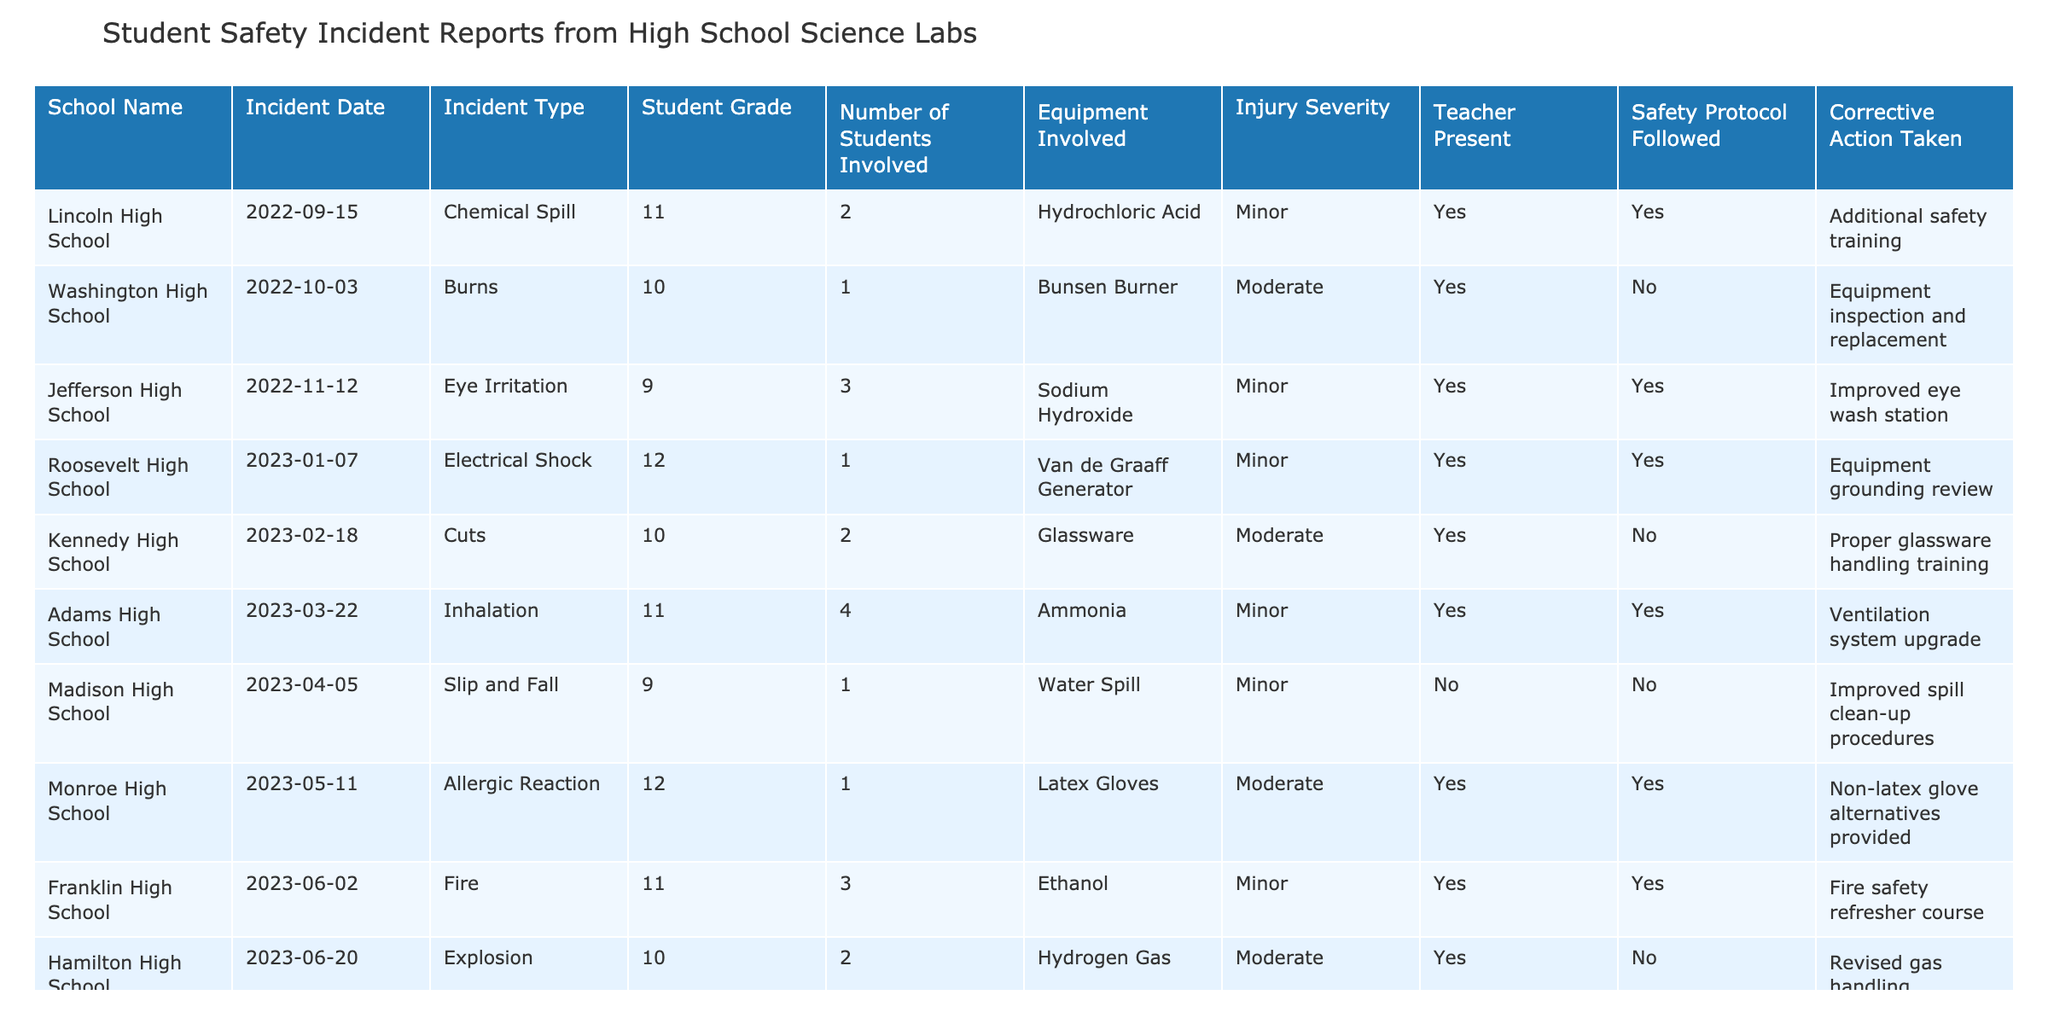What is the incident type reported by Madison High School? Madison High School reported a "Slip and Fall" incident, as stated clearly in the table under the "Incident Type" column associated with that school.
Answer: Slip and Fall How many students were involved in the incident at Kennedy High School? The table indicates that 2 students were involved in the incident reported by Kennedy High School. This can be found in the "Number of Students Involved" column.
Answer: 2 Which school had an incident involving an explosion? The table shows that Hamilton High School had an incident involving an "Explosion." This information is directly available under the "Incident Type" column for Hamilton High School.
Answer: Hamilton High School Was a teacher present during the electrical shock incident at Roosevelt High School? According to the table, a teacher was present during the incident at Roosevelt High School, as indicated by "Yes" in the "Teacher Present" column.
Answer: Yes What was the injury severity for the chemical spill at Lincoln High School? The injury severity for the chemical spill at Lincoln High School is classified as "Minor," which can be found in the "Injury Severity" column for that school.
Answer: Minor How many incidents involved equipment that was not inspected or had not followed safety protocols? Looking at the table, there are 3 incidents (Washington High School, Kennedy High School, Hamilton High School) where either equipment inspection was not done or safety protocols were not followed. Therefore, we count these occurrences: Washington (No), Kennedy (No), and Hamilton (No).
Answer: 3 Which incident had the highest severity? The incidents of "Moderate" severity were reported at Washington High School, Kennedy High School, Hamilton High School, and Monroe High School, indicating these are more severe compared to "Minor." Thus, multiple schools had incidents of the highest severity.
Answer: 4 incidents What corrective action was taken for the explosion incident at Hamilton High School? For the explosion incident at Hamilton High School, the corrective action taken was "Revised gas handling protocols," as noted in the table under the corresponding school and incident type.
Answer: Revised gas handling protocols What percentage of incidents involved a teacher being present? To calculate the percentage, we must first count the total number of incidents, which is 10. Out of these, 7 incidents had a teacher present. The percentage is (7/10) * 100 = 70%.
Answer: 70% Did Franklin High School follow safety protocols during their incident? The table indicates that safety protocols were followed at Franklin High School, as evident from "Yes" in the "Safety Protocol Followed" column.
Answer: Yes Which incident type was the least reported in the table? Referring to the table data, the "Allergic Reaction" incident type was reported only once (Monroe High School), making it the least reported type compared to others.
Answer: Allergic Reaction 